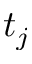Convert formula to latex. <formula><loc_0><loc_0><loc_500><loc_500>t _ { j }</formula> 